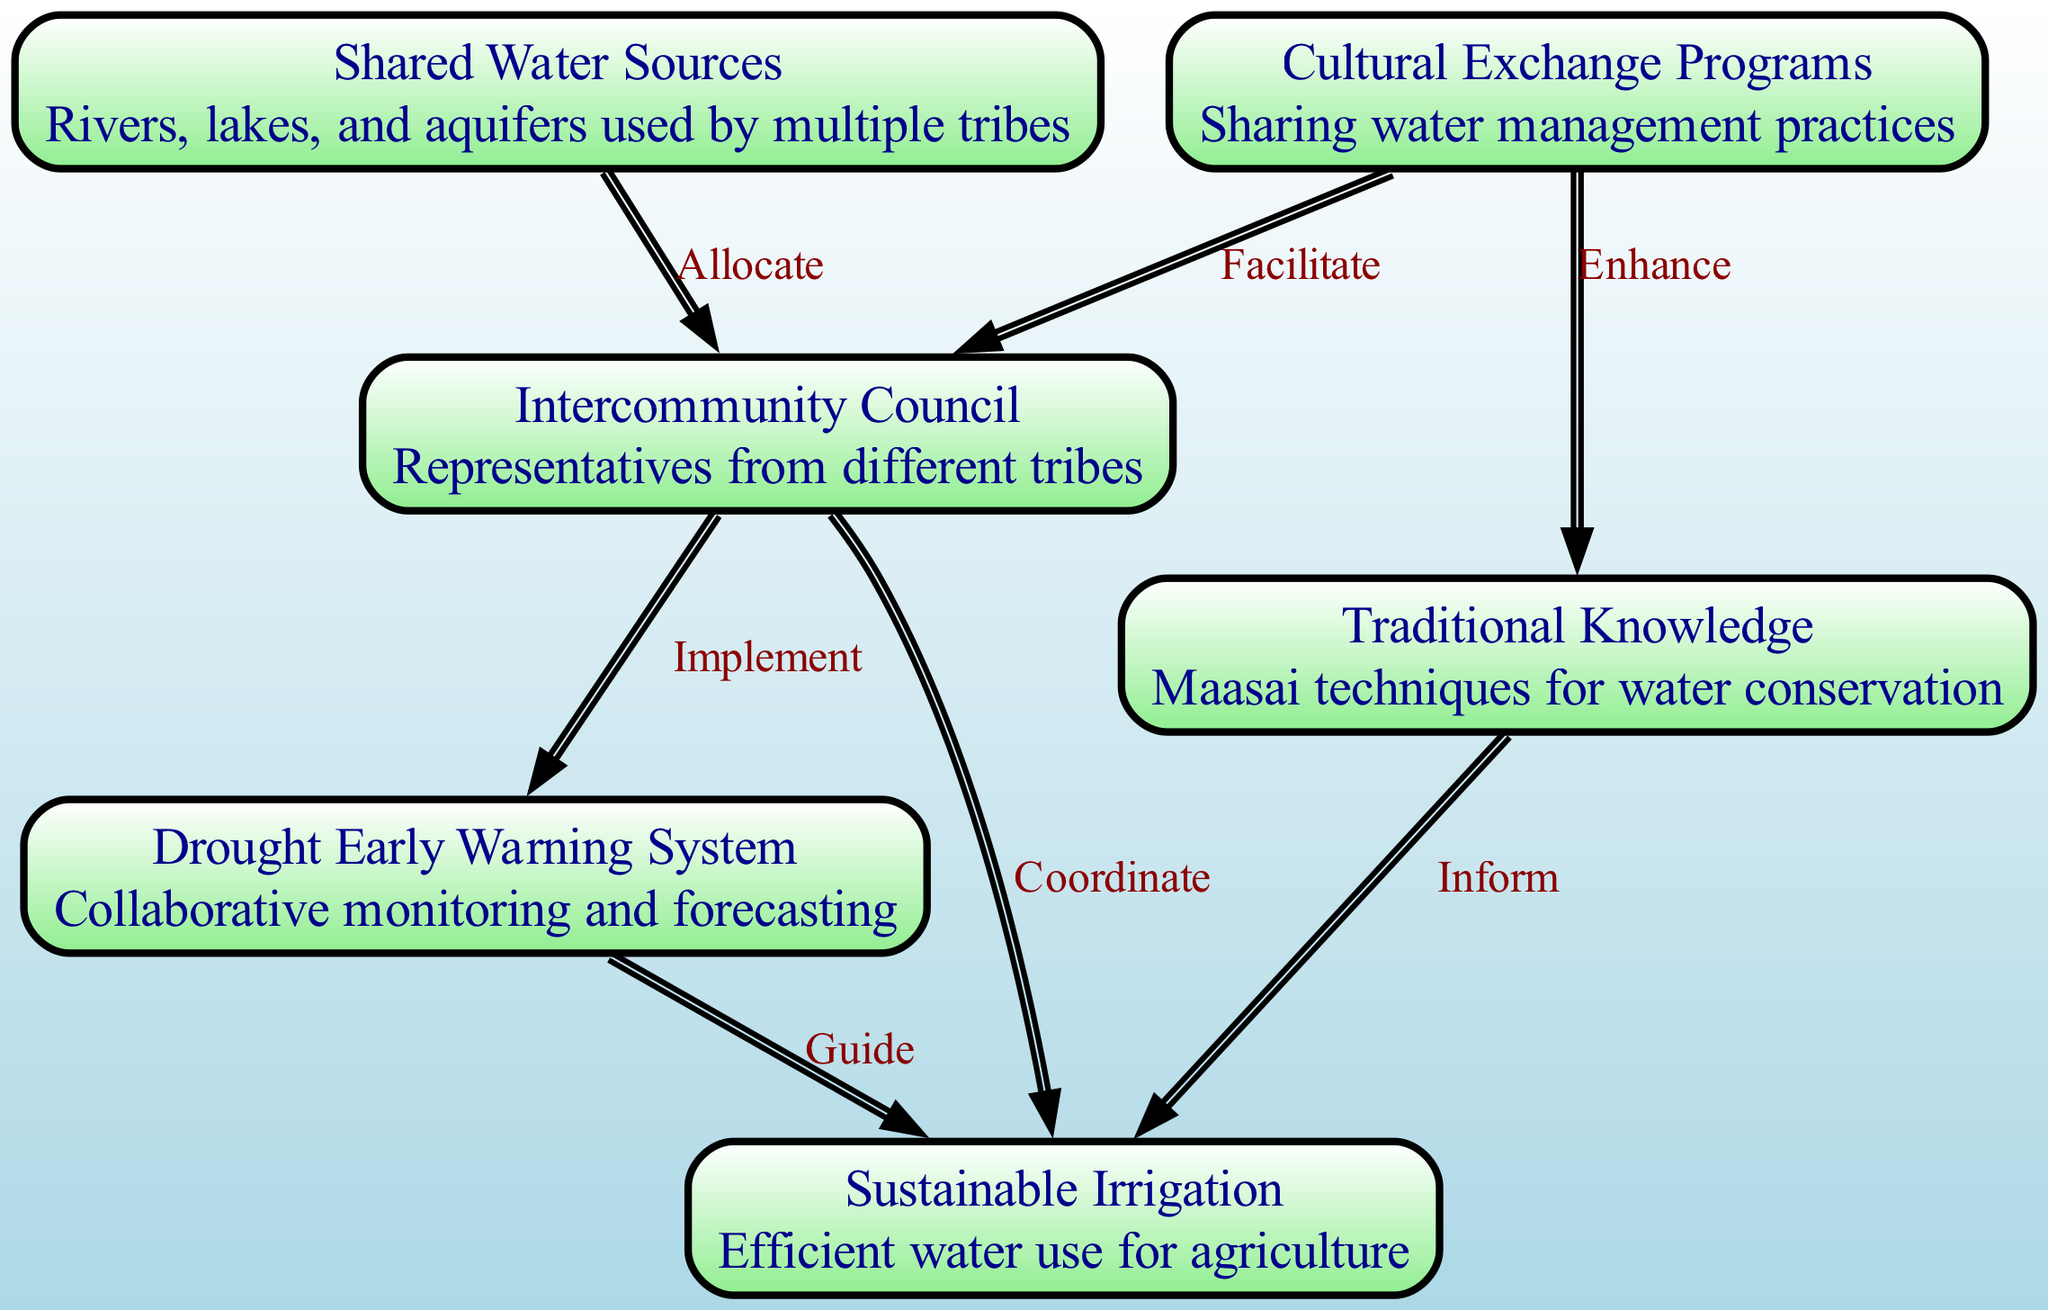What are the shared water sources in this management strategy? The diagram identifies "Shared Water Sources" as rivers, lakes, and aquifers used by multiple tribes, indicated as a node in the diagram.
Answer: Shared Water Sources How many nodes are present in the diagram? By counting the different entities represented in the diagram, we find there are six distinct nodes listed: Shared Water Sources, Traditional Knowledge, Intercommunity Council, Drought Early Warning System, Sustainable Irrigation, and Cultural Exchange Programs.
Answer: 6 What role does the Intercommunity Council play in the diagram? The Intercommunity Council connects various nodes, particularly shown with edges to Shared Water Sources, Drought Early Warning System, and Sustainable Irrigation, indicating its role in allocating water resources and coordinating efforts among tribes.
Answer: Allocate, Implement, Coordinate Which node provides techniques for water conservation? The node labeled "Traditional Knowledge" explicitly mentions techniques for water conservation, making it clear that this is the key source for such practices in the diagram.
Answer: Traditional Knowledge What relationship does the Drought Early Warning System have with Sustainable Irrigation? The relationship is indicated by an edge labeled "Guide," showing that the Drought Early Warning System provides guidance to Sustainable Irrigation, which underscores the collaborative approach to drought management among tribes.
Answer: Guide How does Cultural Exchange Programs enhance Traditional Knowledge? The diagram shows an edge labeled "Enhance" from Cultural Exchange Programs to Traditional Knowledge, indicating that sharing practices from different tribes improves the overall knowledge about water management techniques.
Answer: Enhance What is the purpose of the Drought Early Warning System? The diagram characterizes the Drought Early Warning System as a "Collaborative monitoring and forecasting," highlighting its essential role in anticipating drought conditions to inform resource management decisions.
Answer: Collaborative monitoring and forecasting What is the primary function of the Intercommunity Council? The Intercommunity Council acts as representatives from different tribes, facilitating communication and cooperation, which is depicted through its connections to other nodes in managing shared water resources.
Answer: Representatives from different tribes In how many connections is the Cultural Exchange Programs involved? The Cultural Exchange Programs are involved in two connections, as it has edges to both Traditional Knowledge and Intercommunity Council, indicating its dual role in enhancing knowledge and facilitating cooperation.
Answer: 2 